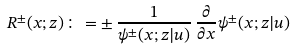<formula> <loc_0><loc_0><loc_500><loc_500>R ^ { \pm } ( x ; z ) \colon = \pm \, \frac { 1 } { \psi ^ { \pm } ( x ; z | u ) } \, \frac { \partial } { \partial x } { \psi ^ { \pm } ( x ; z | u ) } \,</formula> 